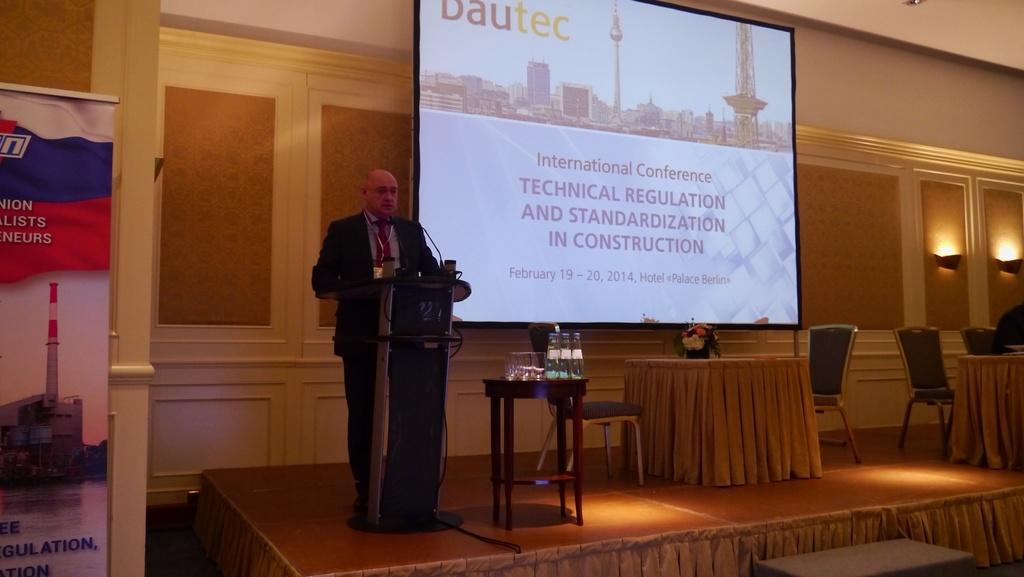How would you summarize this image in a sentence or two? In this picture we can see man standing at podium and talking on mic and beside to him we can see screen, table, chairs and on table we have glasses, bottles, flower pot and in background we can see lights, banners. 